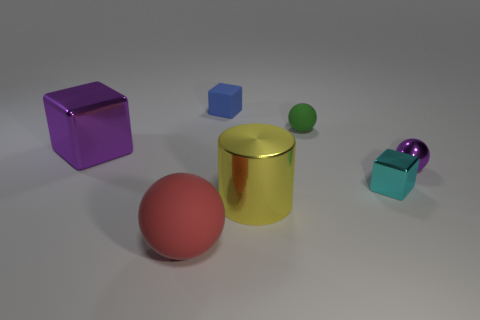Add 1 green rubber balls. How many objects exist? 8 Subtract all cubes. How many objects are left? 4 Add 1 purple metallic things. How many purple metallic things exist? 3 Subtract 0 yellow spheres. How many objects are left? 7 Subtract all small purple metal objects. Subtract all small cyan blocks. How many objects are left? 5 Add 7 green rubber things. How many green rubber things are left? 8 